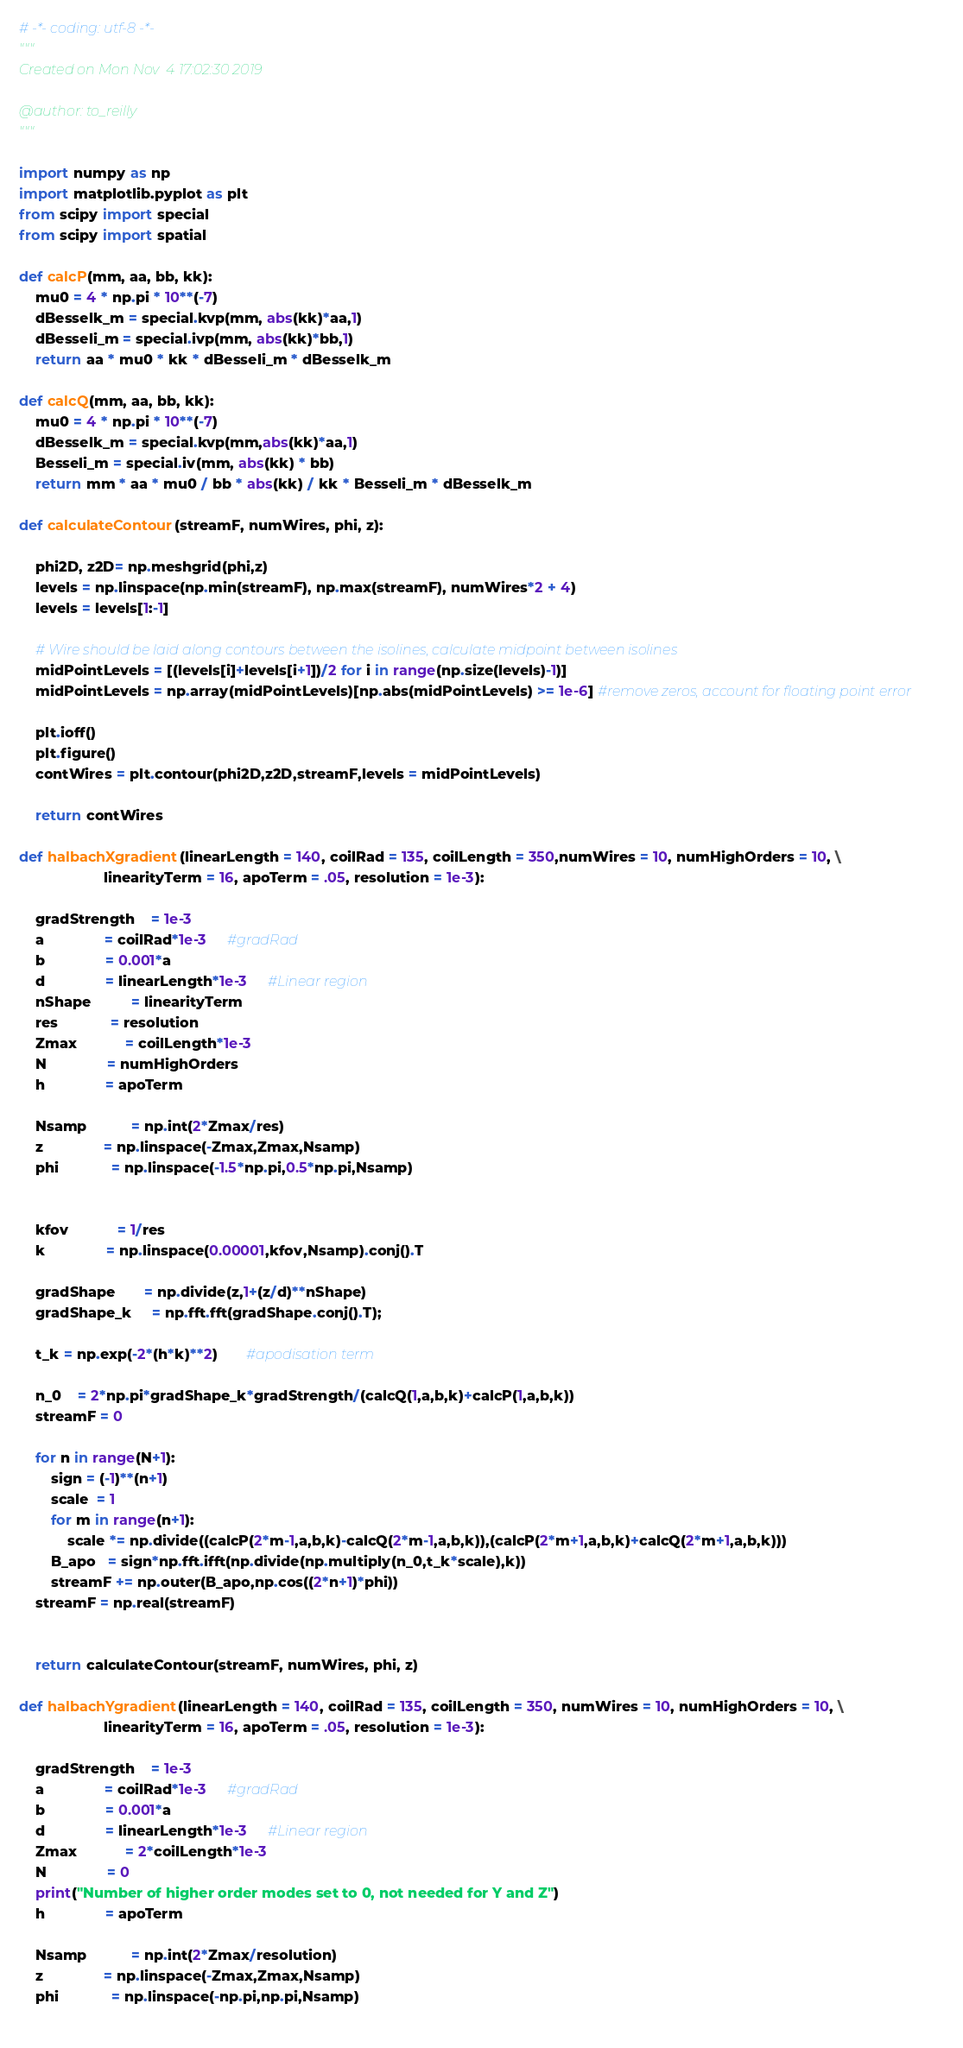<code> <loc_0><loc_0><loc_500><loc_500><_Python_># -*- coding: utf-8 -*-
"""
Created on Mon Nov  4 17:02:30 2019

@author: to_reilly
"""

import numpy as np
import matplotlib.pyplot as plt
from scipy import special
from scipy import spatial

def calcP(mm, aa, bb, kk):
    mu0 = 4 * np.pi * 10**(-7)
    dBesselk_m = special.kvp(mm, abs(kk)*aa,1)
    dBesseli_m = special.ivp(mm, abs(kk)*bb,1)
    return aa * mu0 * kk * dBesseli_m * dBesselk_m

def calcQ(mm, aa, bb, kk):
    mu0 = 4 * np.pi * 10**(-7)
    dBesselk_m = special.kvp(mm,abs(kk)*aa,1)
    Besseli_m = special.iv(mm, abs(kk) * bb)
    return mm * aa * mu0 / bb * abs(kk) / kk * Besseli_m * dBesselk_m

def calculateContour(streamF, numWires, phi, z):
    
    phi2D, z2D= np.meshgrid(phi,z)
    levels = np.linspace(np.min(streamF), np.max(streamF), numWires*2 + 4)
    levels = levels[1:-1]

    # Wire should be laid along contours between the isolines, calculate midpoint between isolines
    midPointLevels = [(levels[i]+levels[i+1])/2 for i in range(np.size(levels)-1)]
    midPointLevels = np.array(midPointLevels)[np.abs(midPointLevels) >= 1e-6] #remove zeros, account for floating point error
    
    plt.ioff()
    plt.figure()
    contWires = plt.contour(phi2D,z2D,streamF,levels = midPointLevels)
    
    return contWires

def halbachXgradient(linearLength = 140, coilRad = 135, coilLength = 350,numWires = 10, numHighOrders = 10, \
                     linearityTerm = 16, apoTerm = .05, resolution = 1e-3):
    
    gradStrength    = 1e-3
    a               = coilRad*1e-3     #gradRad
    b               = 0.001*a
    d               = linearLength*1e-3     #Linear region 
    nShape          = linearityTerm
    res             = resolution
    Zmax            = coilLength*1e-3
    N               = numHighOrders
    h               = apoTerm
    
    Nsamp           = np.int(2*Zmax/res)
    z               = np.linspace(-Zmax,Zmax,Nsamp)
    phi             = np.linspace(-1.5*np.pi,0.5*np.pi,Nsamp)
    
    
    kfov            = 1/res
    k               = np.linspace(0.00001,kfov,Nsamp).conj().T
    
    gradShape       = np.divide(z,1+(z/d)**nShape)
    gradShape_k     = np.fft.fft(gradShape.conj().T);
    
    t_k = np.exp(-2*(h*k)**2)       #apodisation term
    
    n_0    = 2*np.pi*gradShape_k*gradStrength/(calcQ(1,a,b,k)+calcP(1,a,b,k))
    streamF = 0
    
    for n in range(N+1):
        sign = (-1)**(n+1)
        scale  = 1
        for m in range(n+1):
            scale *= np.divide((calcP(2*m-1,a,b,k)-calcQ(2*m-1,a,b,k)),(calcP(2*m+1,a,b,k)+calcQ(2*m+1,a,b,k)))
        B_apo   = sign*np.fft.ifft(np.divide(np.multiply(n_0,t_k*scale),k)) 
        streamF += np.outer(B_apo,np.cos((2*n+1)*phi))
    streamF = np.real(streamF)
    

    return calculateContour(streamF, numWires, phi, z)

def halbachYgradient(linearLength = 140, coilRad = 135, coilLength = 350, numWires = 10, numHighOrders = 10, \
                     linearityTerm = 16, apoTerm = .05, resolution = 1e-3):
    
    gradStrength    = 1e-3
    a               = coilRad*1e-3     #gradRad
    b               = 0.001*a
    d               = linearLength*1e-3     #Linear region 
    Zmax            = 2*coilLength*1e-3
    N               = 0
    print("Number of higher order modes set to 0, not needed for Y and Z")
    h               = apoTerm
    
    Nsamp           = np.int(2*Zmax/resolution)
    z               = np.linspace(-Zmax,Zmax,Nsamp)
    phi             = np.linspace(-np.pi,np.pi,Nsamp)
    </code> 